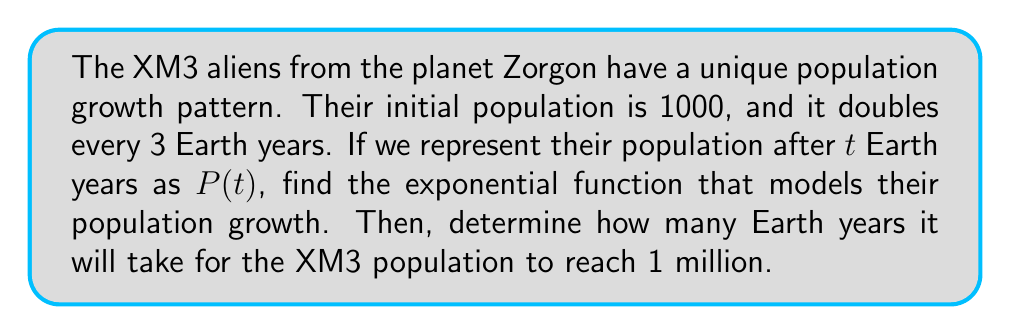What is the answer to this math problem? Let's approach this step-by-step:

1) The general form of an exponential function is:
   $P(t) = P_0 \cdot b^{t/k}$
   where $P_0$ is the initial population, $b$ is the growth factor, $t$ is time, and $k$ is the time it takes for one growth cycle.

2) We know:
   - $P_0 = 1000$ (initial population)
   - The population doubles every 3 years, so $b = 2$ and $k = 3$

3) Substituting these values into our general form:
   $P(t) = 1000 \cdot 2^{t/3}$

4) To find when the population reaches 1 million, we set up the equation:
   $1000 \cdot 2^{t/3} = 1,000,000$

5) Simplify:
   $2^{t/3} = 1000$

6) Take $\log_2$ of both sides:
   $\frac{t}{3} = \log_2(1000)$

7) Multiply both sides by 3:
   $t = 3 \cdot \log_2(1000) \approx 29.897$ Earth years

Therefore, it will take approximately 29.897 Earth years for the XM3 population to reach 1 million.
Answer: $P(t) = 1000 \cdot 2^{t/3}$; 29.897 Earth years 